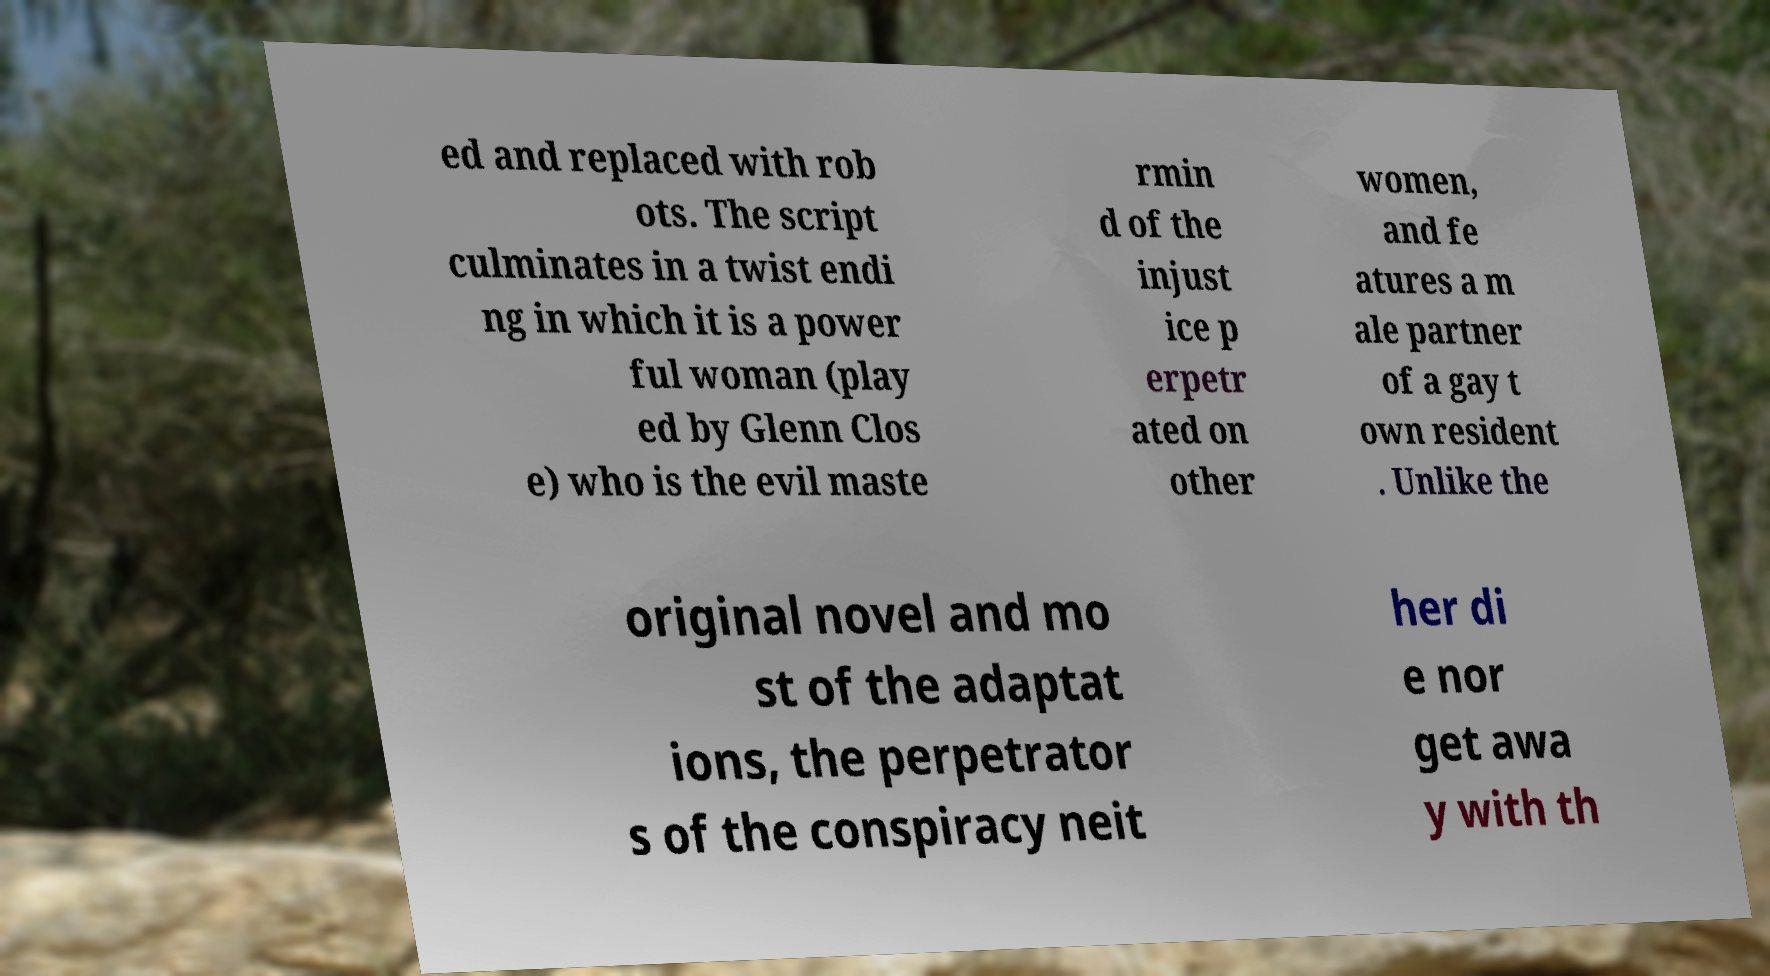Please identify and transcribe the text found in this image. ed and replaced with rob ots. The script culminates in a twist endi ng in which it is a power ful woman (play ed by Glenn Clos e) who is the evil maste rmin d of the injust ice p erpetr ated on other women, and fe atures a m ale partner of a gay t own resident . Unlike the original novel and mo st of the adaptat ions, the perpetrator s of the conspiracy neit her di e nor get awa y with th 